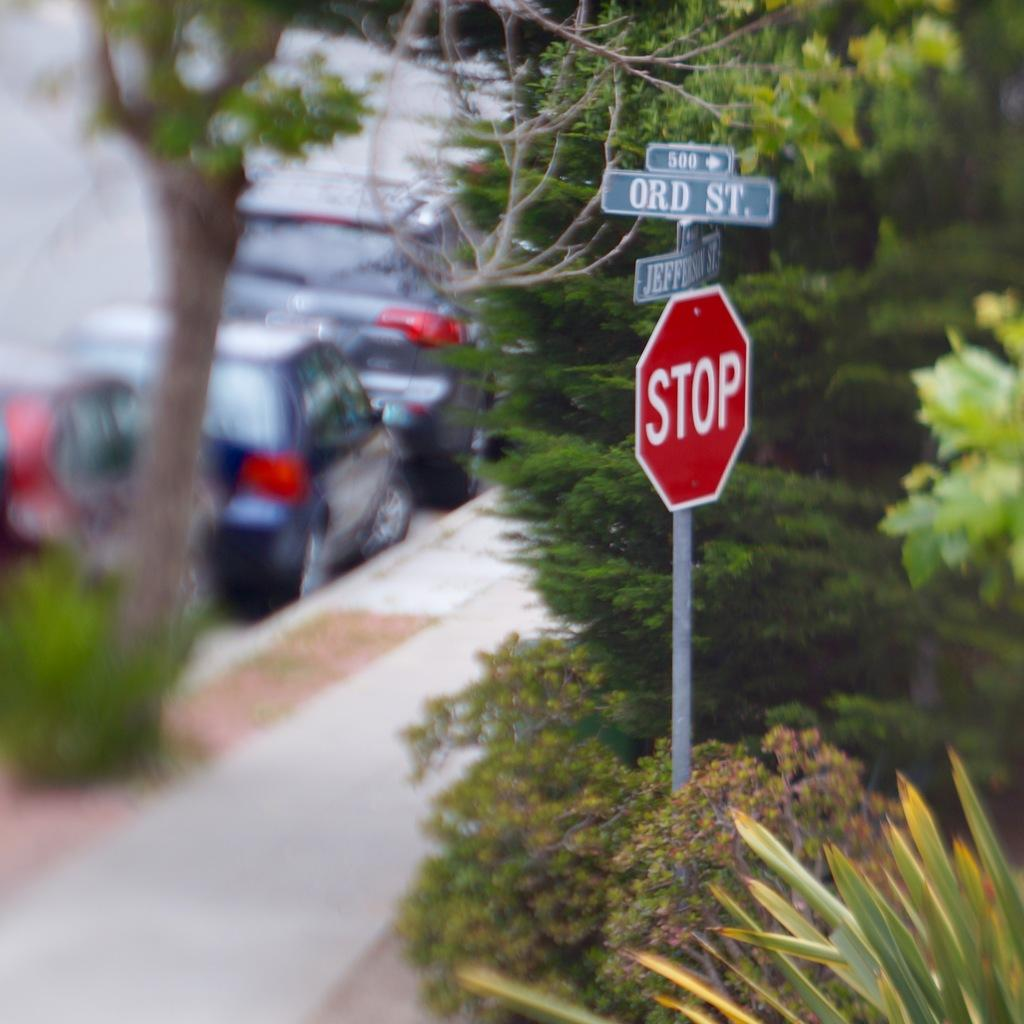What is located on the right side of the image? There is a hoarding on the right side of the image, as well as trees and plants. What is located on the left side of the image? There are trees, plants, and cars on the left side of the image. What is at the bottom of the image? There is a footpath at the bottom of the image. How many fish can be seen swimming in the image? There are no fish present in the image. What type of quilt is draped over the hoarding in the image? There is no quilt present in the image; it features a hoarding, trees, plants, cars, and a footpath. 